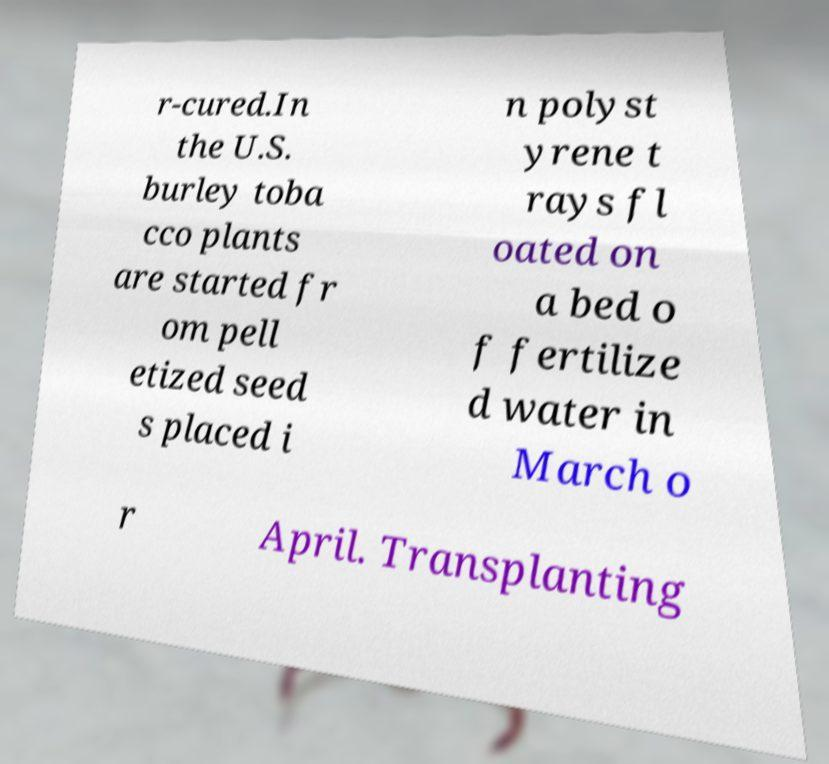What messages or text are displayed in this image? I need them in a readable, typed format. r-cured.In the U.S. burley toba cco plants are started fr om pell etized seed s placed i n polyst yrene t rays fl oated on a bed o f fertilize d water in March o r April. Transplanting 